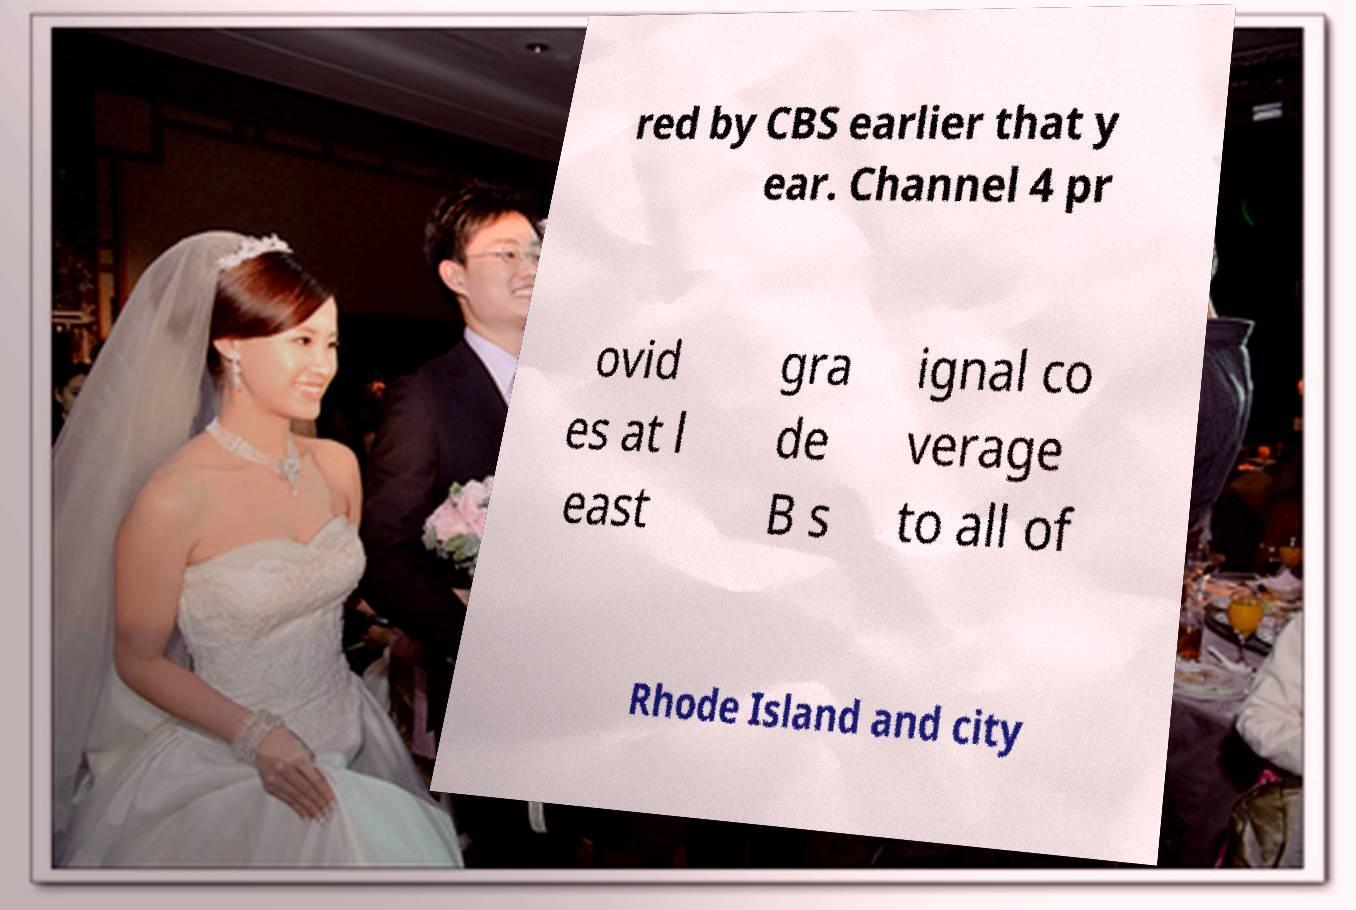There's text embedded in this image that I need extracted. Can you transcribe it verbatim? red by CBS earlier that y ear. Channel 4 pr ovid es at l east gra de B s ignal co verage to all of Rhode Island and city 